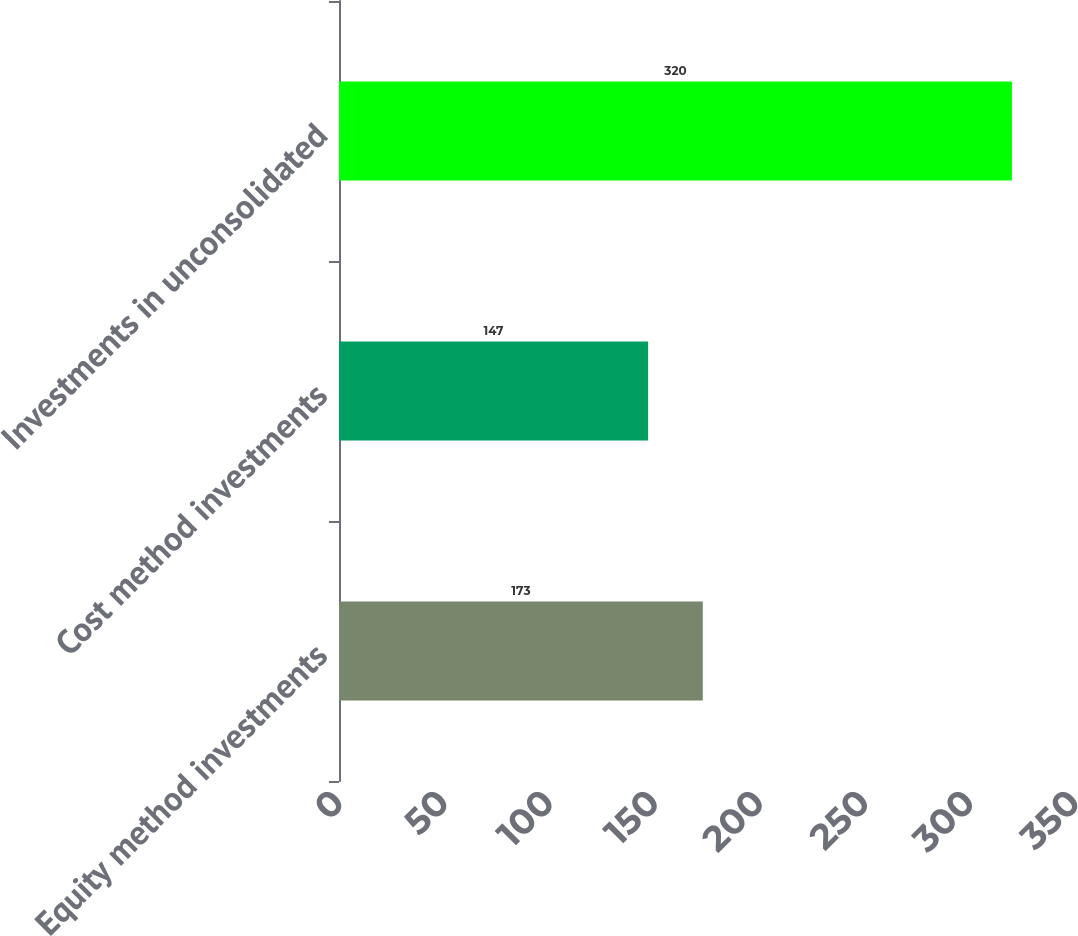Convert chart to OTSL. <chart><loc_0><loc_0><loc_500><loc_500><bar_chart><fcel>Equity method investments<fcel>Cost method investments<fcel>Investments in unconsolidated<nl><fcel>173<fcel>147<fcel>320<nl></chart> 